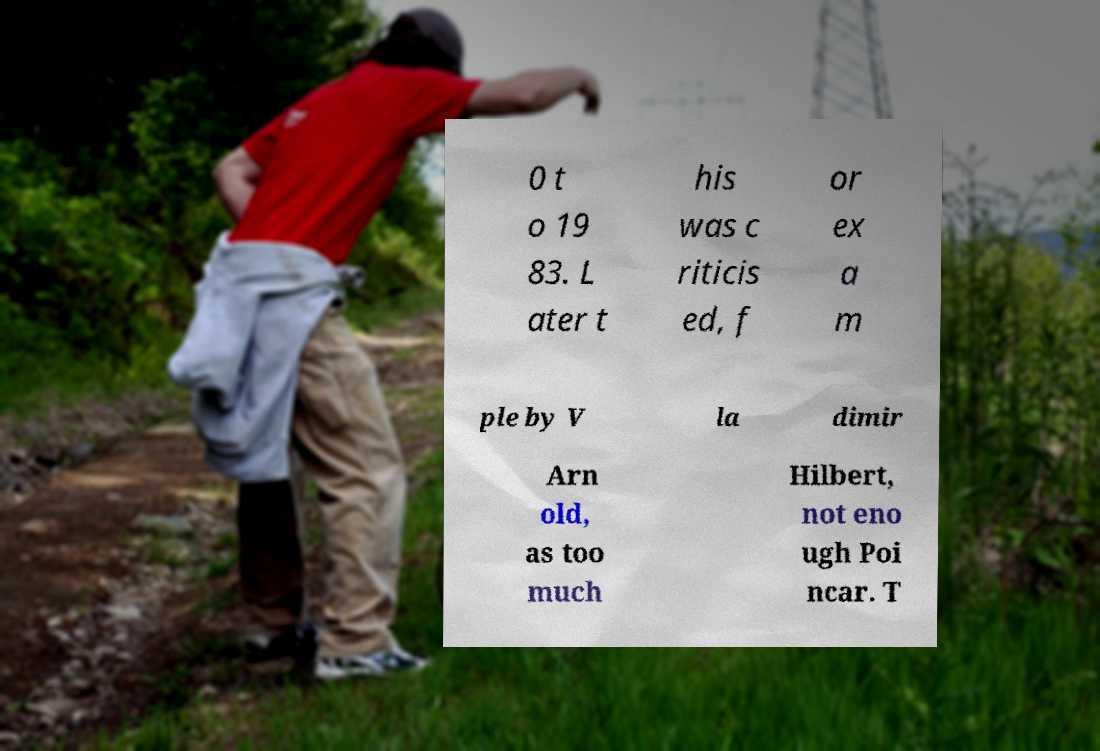Can you accurately transcribe the text from the provided image for me? 0 t o 19 83. L ater t his was c riticis ed, f or ex a m ple by V la dimir Arn old, as too much Hilbert, not eno ugh Poi ncar. T 